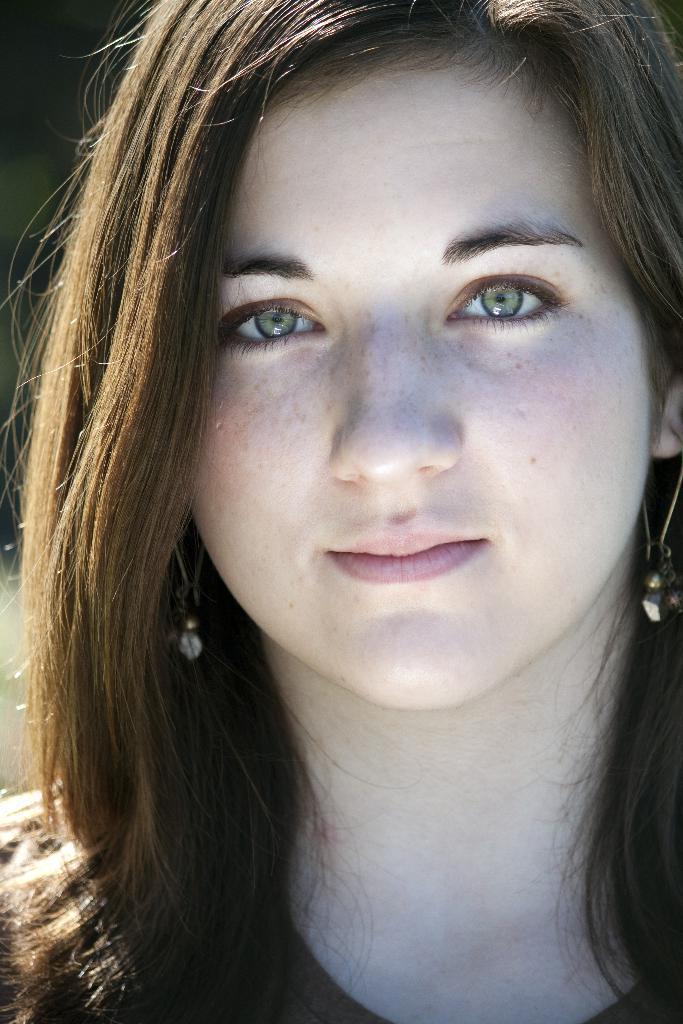Describe this image in one or two sentences. In this image I can see a woman posing for the picture. 